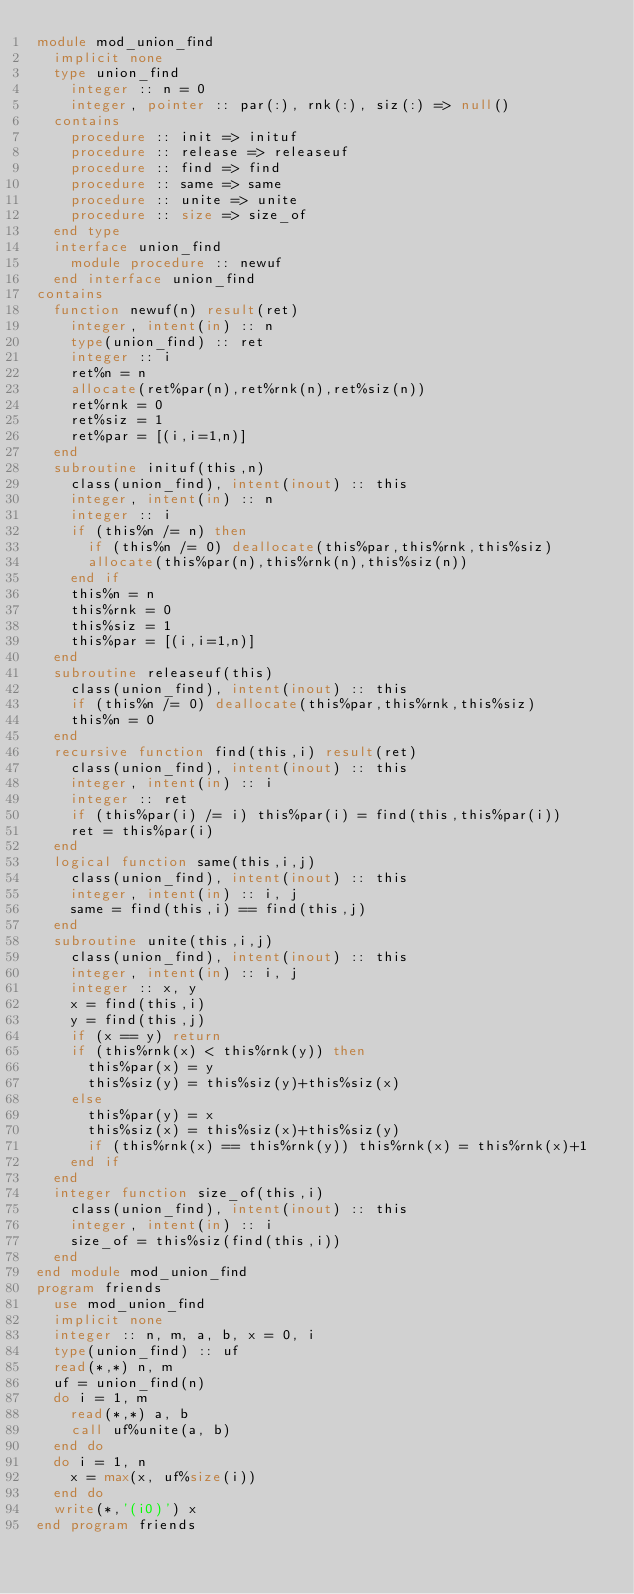Convert code to text. <code><loc_0><loc_0><loc_500><loc_500><_FORTRAN_>module mod_union_find
  implicit none
  type union_find
    integer :: n = 0
    integer, pointer :: par(:), rnk(:), siz(:) => null()
  contains
    procedure :: init => inituf
    procedure :: release => releaseuf
    procedure :: find => find
    procedure :: same => same
    procedure :: unite => unite
    procedure :: size => size_of
  end type
  interface union_find
    module procedure :: newuf
  end interface union_find
contains
  function newuf(n) result(ret)
    integer, intent(in) :: n
    type(union_find) :: ret
    integer :: i
    ret%n = n
    allocate(ret%par(n),ret%rnk(n),ret%siz(n))
    ret%rnk = 0
    ret%siz = 1
    ret%par = [(i,i=1,n)]
  end
  subroutine inituf(this,n)
    class(union_find), intent(inout) :: this
    integer, intent(in) :: n
    integer :: i
    if (this%n /= n) then
      if (this%n /= 0) deallocate(this%par,this%rnk,this%siz)
      allocate(this%par(n),this%rnk(n),this%siz(n))
    end if
    this%n = n
    this%rnk = 0
    this%siz = 1
    this%par = [(i,i=1,n)]
  end
  subroutine releaseuf(this)
    class(union_find), intent(inout) :: this
    if (this%n /= 0) deallocate(this%par,this%rnk,this%siz)
    this%n = 0
  end
  recursive function find(this,i) result(ret)
    class(union_find), intent(inout) :: this
    integer, intent(in) :: i
    integer :: ret
    if (this%par(i) /= i) this%par(i) = find(this,this%par(i))
    ret = this%par(i)
  end
  logical function same(this,i,j)
    class(union_find), intent(inout) :: this
    integer, intent(in) :: i, j
    same = find(this,i) == find(this,j)
  end
  subroutine unite(this,i,j)
    class(union_find), intent(inout) :: this
    integer, intent(in) :: i, j
    integer :: x, y
    x = find(this,i)
    y = find(this,j)
    if (x == y) return
    if (this%rnk(x) < this%rnk(y)) then
      this%par(x) = y
      this%siz(y) = this%siz(y)+this%siz(x)
    else
      this%par(y) = x
      this%siz(x) = this%siz(x)+this%siz(y)
      if (this%rnk(x) == this%rnk(y)) this%rnk(x) = this%rnk(x)+1
    end if
  end
  integer function size_of(this,i)
    class(union_find), intent(inout) :: this
    integer, intent(in) :: i
    size_of = this%siz(find(this,i))
  end
end module mod_union_find
program friends
  use mod_union_find
  implicit none
  integer :: n, m, a, b, x = 0, i
  type(union_find) :: uf
  read(*,*) n, m
  uf = union_find(n)
  do i = 1, m
    read(*,*) a, b
    call uf%unite(a, b)
  end do
  do i = 1, n
    x = max(x, uf%size(i))
  end do
  write(*,'(i0)') x
end program friends</code> 